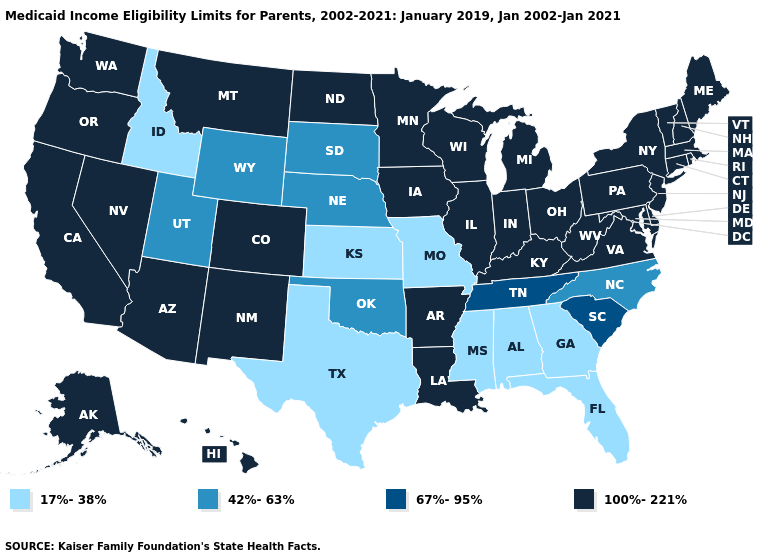What is the lowest value in the USA?
Concise answer only. 17%-38%. Name the states that have a value in the range 42%-63%?
Concise answer only. Nebraska, North Carolina, Oklahoma, South Dakota, Utah, Wyoming. Does the map have missing data?
Answer briefly. No. What is the lowest value in the USA?
Quick response, please. 17%-38%. What is the highest value in states that border Rhode Island?
Write a very short answer. 100%-221%. Does West Virginia have the same value as Texas?
Concise answer only. No. Name the states that have a value in the range 100%-221%?
Be succinct. Alaska, Arizona, Arkansas, California, Colorado, Connecticut, Delaware, Hawaii, Illinois, Indiana, Iowa, Kentucky, Louisiana, Maine, Maryland, Massachusetts, Michigan, Minnesota, Montana, Nevada, New Hampshire, New Jersey, New Mexico, New York, North Dakota, Ohio, Oregon, Pennsylvania, Rhode Island, Vermont, Virginia, Washington, West Virginia, Wisconsin. What is the value of Nevada?
Quick response, please. 100%-221%. What is the value of West Virginia?
Short answer required. 100%-221%. Name the states that have a value in the range 42%-63%?
Give a very brief answer. Nebraska, North Carolina, Oklahoma, South Dakota, Utah, Wyoming. Which states have the lowest value in the MidWest?
Give a very brief answer. Kansas, Missouri. What is the highest value in states that border Colorado?
Concise answer only. 100%-221%. Which states have the lowest value in the USA?
Be succinct. Alabama, Florida, Georgia, Idaho, Kansas, Mississippi, Missouri, Texas. Does Wisconsin have the highest value in the MidWest?
Quick response, please. Yes. Name the states that have a value in the range 42%-63%?
Short answer required. Nebraska, North Carolina, Oklahoma, South Dakota, Utah, Wyoming. 